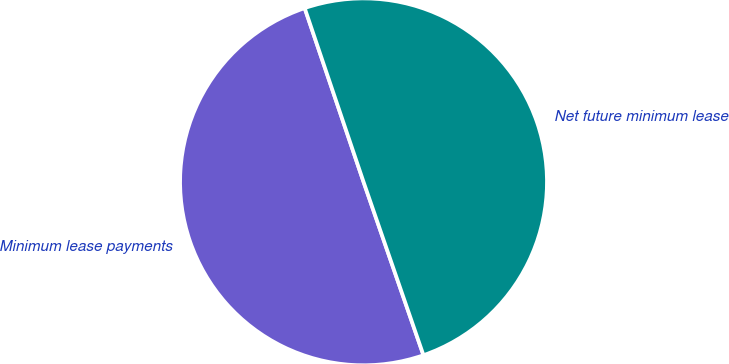Convert chart. <chart><loc_0><loc_0><loc_500><loc_500><pie_chart><fcel>Minimum lease payments<fcel>Net future minimum lease<nl><fcel>50.1%<fcel>49.9%<nl></chart> 